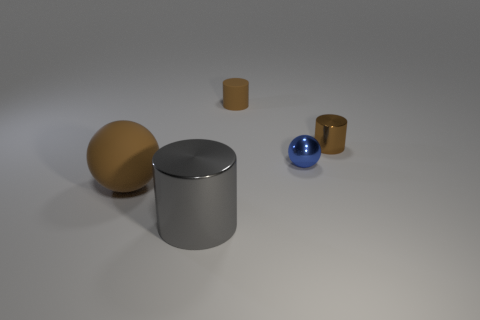What color is the matte object left of the large thing in front of the sphere to the left of the small blue shiny sphere?
Make the answer very short. Brown. The other cylinder that is the same size as the rubber cylinder is what color?
Your answer should be compact. Brown. There is a brown thing that is on the left side of the brown rubber cylinder to the left of the small brown shiny thing that is on the right side of the big metal cylinder; what is its shape?
Offer a terse response. Sphere. There is a metallic thing that is the same color as the small matte cylinder; what is its shape?
Offer a very short reply. Cylinder. What number of things are either large rubber balls or brown matte things that are to the left of the gray object?
Offer a terse response. 1. There is a shiny cylinder that is on the right side of the rubber cylinder; is its size the same as the gray object?
Keep it short and to the point. No. There is a ball that is behind the matte ball; what is it made of?
Provide a succinct answer. Metal. Is the number of brown rubber things on the left side of the brown matte sphere the same as the number of brown objects that are left of the blue metallic sphere?
Provide a succinct answer. No. What color is the other large thing that is the same shape as the brown metallic object?
Your response must be concise. Gray. Is there any other thing that has the same color as the big matte object?
Offer a very short reply. Yes. 